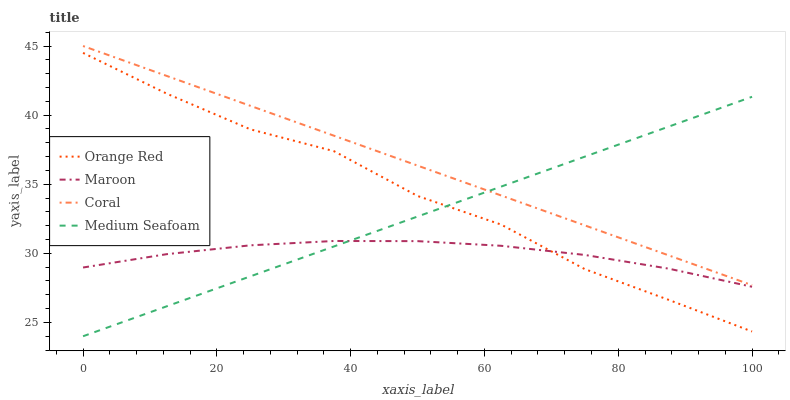Does Maroon have the minimum area under the curve?
Answer yes or no. Yes. Does Coral have the maximum area under the curve?
Answer yes or no. Yes. Does Orange Red have the minimum area under the curve?
Answer yes or no. No. Does Orange Red have the maximum area under the curve?
Answer yes or no. No. Is Coral the smoothest?
Answer yes or no. Yes. Is Orange Red the roughest?
Answer yes or no. Yes. Is Maroon the smoothest?
Answer yes or no. No. Is Maroon the roughest?
Answer yes or no. No. Does Medium Seafoam have the lowest value?
Answer yes or no. Yes. Does Orange Red have the lowest value?
Answer yes or no. No. Does Coral have the highest value?
Answer yes or no. Yes. Does Orange Red have the highest value?
Answer yes or no. No. Is Maroon less than Coral?
Answer yes or no. Yes. Is Coral greater than Maroon?
Answer yes or no. Yes. Does Orange Red intersect Maroon?
Answer yes or no. Yes. Is Orange Red less than Maroon?
Answer yes or no. No. Is Orange Red greater than Maroon?
Answer yes or no. No. Does Maroon intersect Coral?
Answer yes or no. No. 